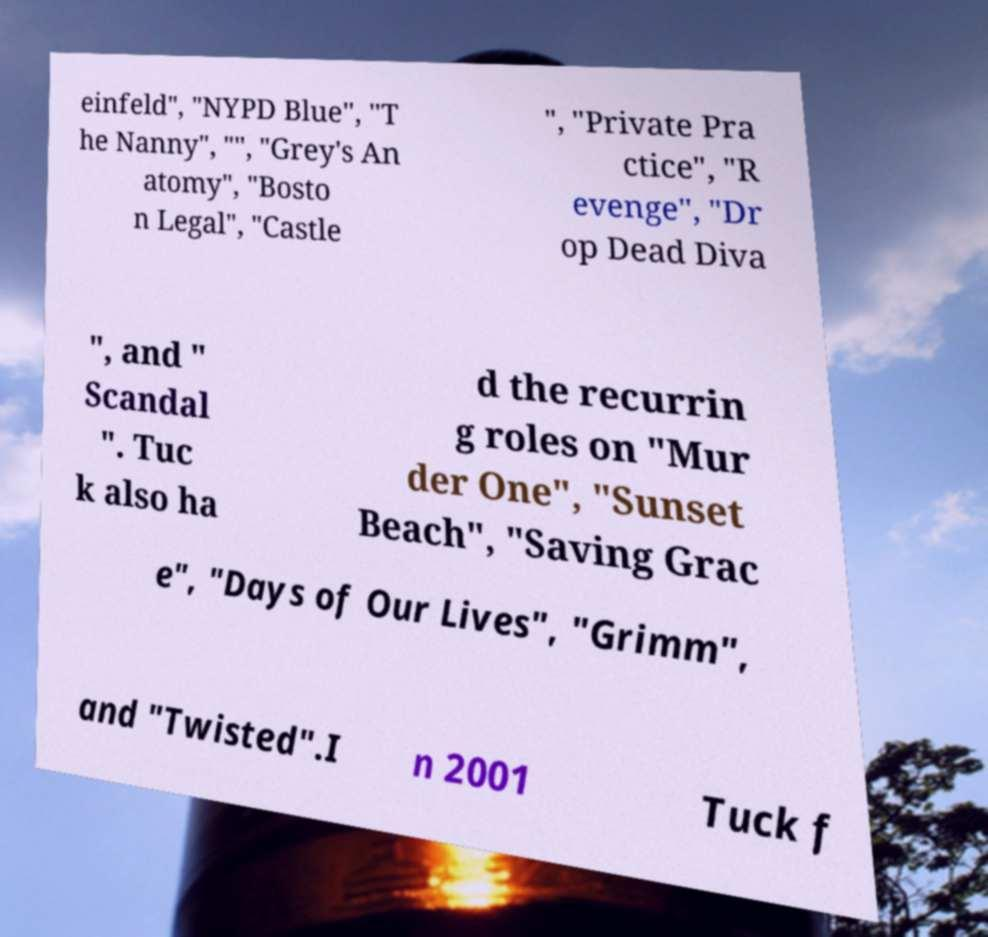I need the written content from this picture converted into text. Can you do that? einfeld", "NYPD Blue", "T he Nanny", "", "Grey's An atomy", "Bosto n Legal", "Castle ", "Private Pra ctice", "R evenge", "Dr op Dead Diva ", and " Scandal ". Tuc k also ha d the recurrin g roles on "Mur der One", "Sunset Beach", "Saving Grac e", "Days of Our Lives", "Grimm", and "Twisted".I n 2001 Tuck f 